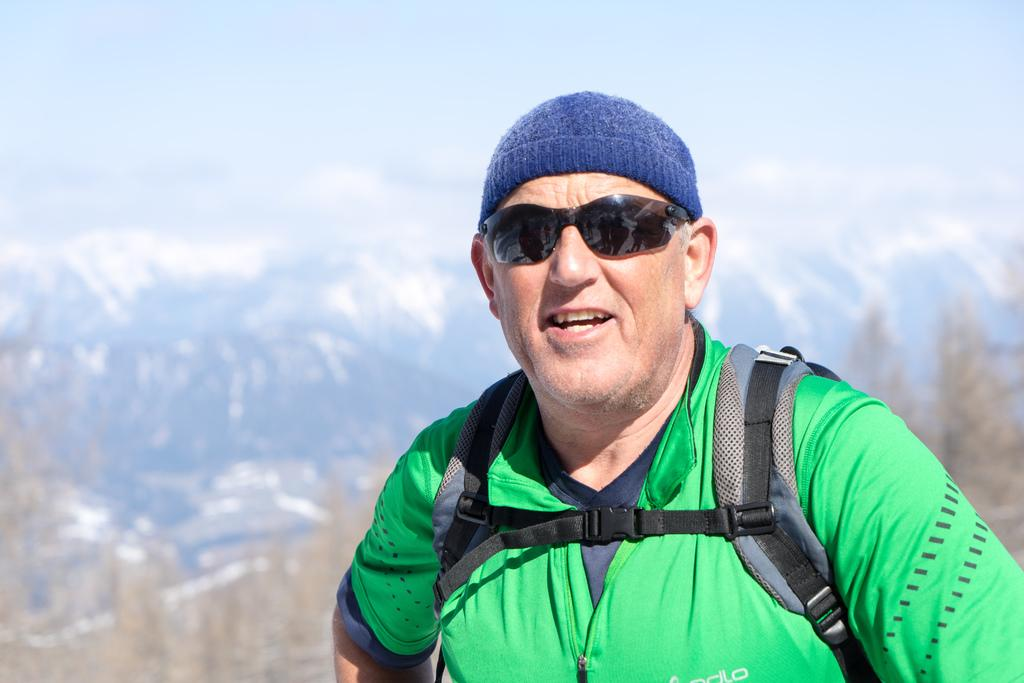Who is present in the image? There is a man in the image. What is the man's facial expression? The man is smiling. What accessories is the man wearing? The man is wearing a cap and goggles. What is the man carrying in the image? The man is carrying a backpack. What can be seen in the background of the image? There are trees in the background of the image. How would you describe the background's appearance? The background of the image is blurry. What type of mask is the man wearing in the image? The man is not wearing a mask in the image; he is wearing goggles. How many times does the man sort the items in the image? There are no items to sort in the image, so the man does not sort anything. 